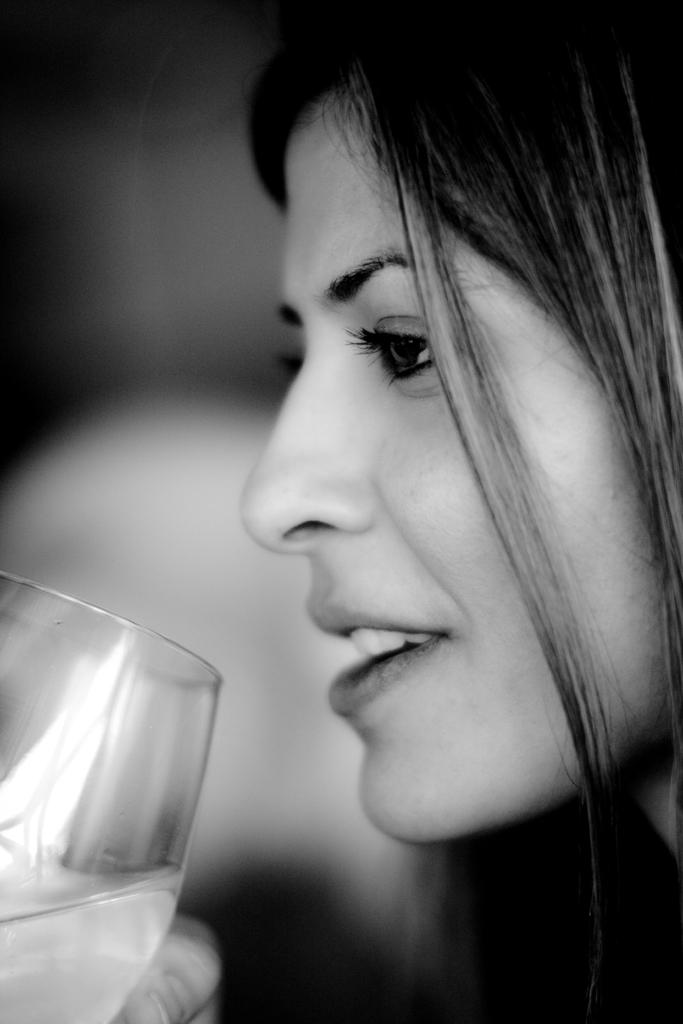Who is present in the image? There is a woman in the image. What is the woman holding in the image? The woman is holding a glass. How many cats can be seen playing with a giraffe in the image? There are no cats or giraffes present in the image; it features a woman holding a glass. 